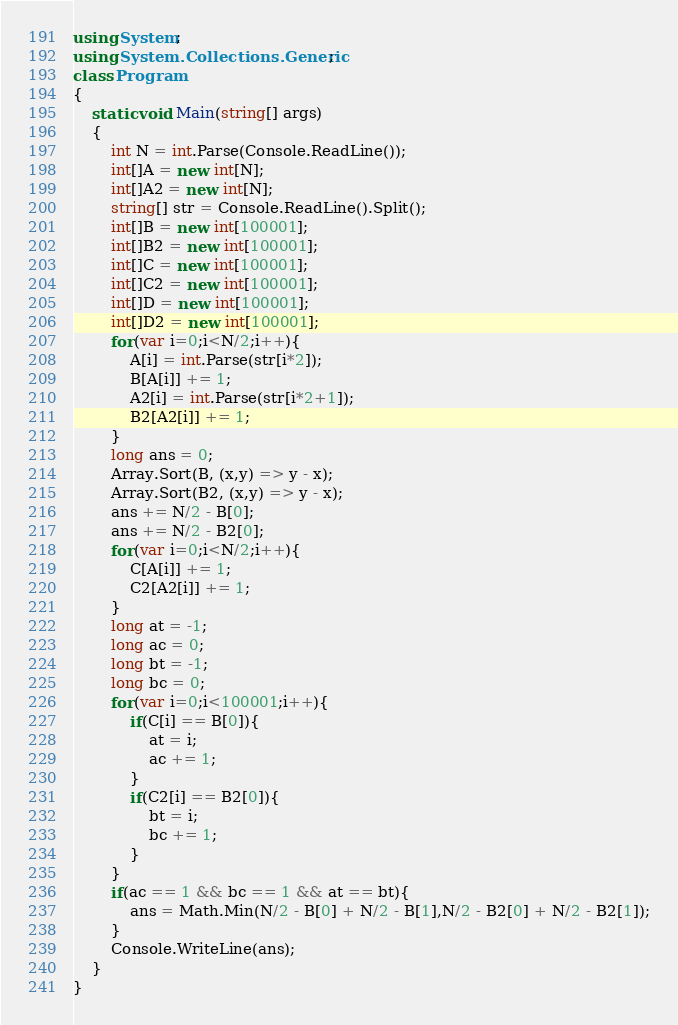Convert code to text. <code><loc_0><loc_0><loc_500><loc_500><_C#_>using System;
using System.Collections.Generic;
class Program
{
	static void Main(string[] args)
	{
		int N = int.Parse(Console.ReadLine());
		int[]A = new int[N];
		int[]A2 = new int[N];
		string[] str = Console.ReadLine().Split();
		int[]B = new int[100001];
		int[]B2 = new int[100001];
		int[]C = new int[100001];
		int[]C2 = new int[100001];
		int[]D = new int[100001];
		int[]D2 = new int[100001];
		for(var i=0;i<N/2;i++){
			A[i] = int.Parse(str[i*2]);
			B[A[i]] += 1;
			A2[i] = int.Parse(str[i*2+1]);
			B2[A2[i]] += 1;
		}
		long ans = 0;
		Array.Sort(B, (x,y) => y - x);
		Array.Sort(B2, (x,y) => y - x);
		ans += N/2 - B[0];
		ans += N/2 - B2[0];
		for(var i=0;i<N/2;i++){
			C[A[i]] += 1;
			C2[A2[i]] += 1;
		}
		long at = -1;
		long ac = 0;
		long bt = -1;
		long bc = 0;
		for(var i=0;i<100001;i++){
			if(C[i] == B[0]){
				at = i;
				ac += 1;
			}
			if(C2[i] == B2[0]){
				bt = i;
				bc += 1;
			}
		}
		if(ac == 1 && bc == 1 && at == bt){
			ans = Math.Min(N/2 - B[0] + N/2 - B[1],N/2 - B2[0] + N/2 - B2[1]);
		}
		Console.WriteLine(ans);
	}
}</code> 